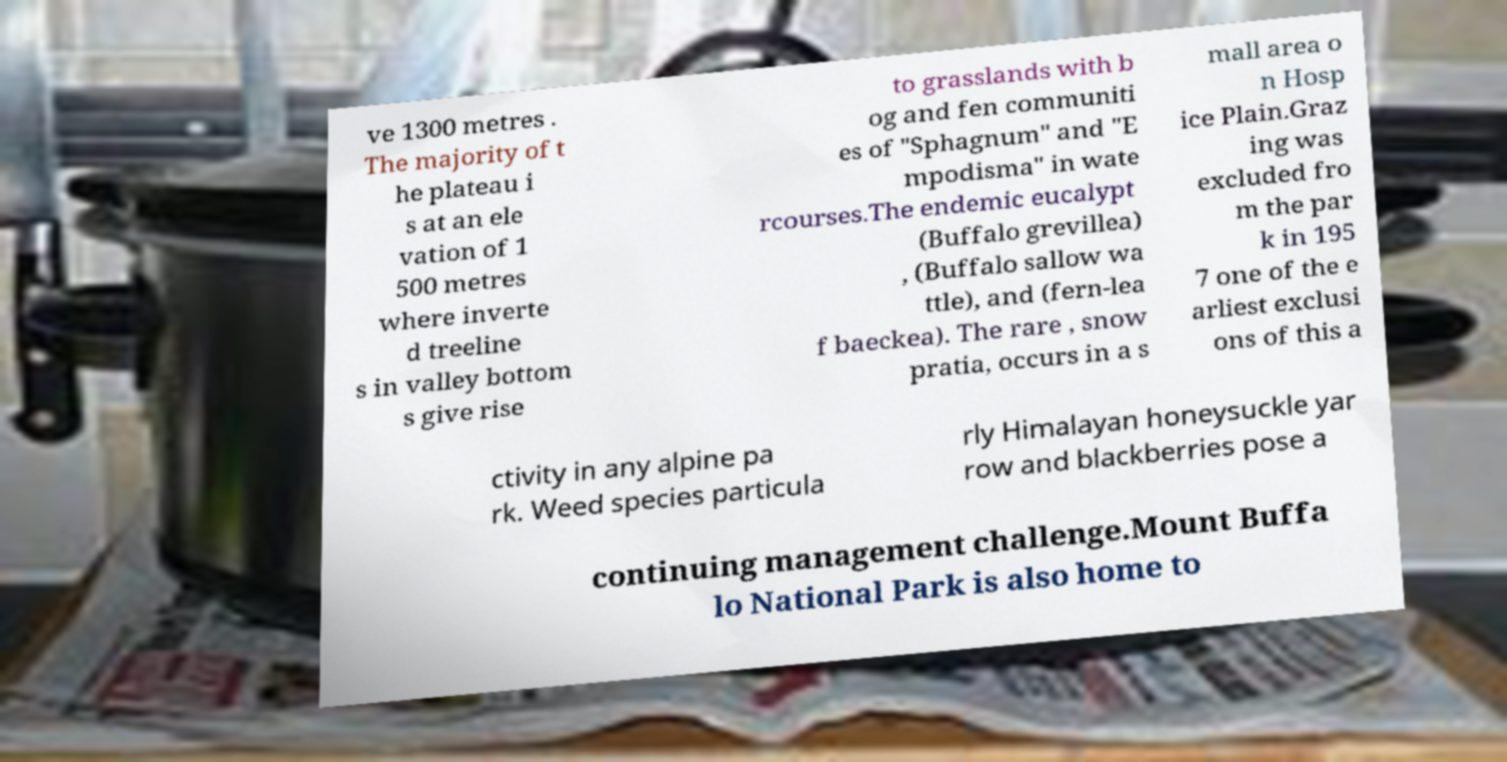Can you read and provide the text displayed in the image?This photo seems to have some interesting text. Can you extract and type it out for me? ve 1300 metres . The majority of t he plateau i s at an ele vation of 1 500 metres where inverte d treeline s in valley bottom s give rise to grasslands with b og and fen communiti es of "Sphagnum" and "E mpodisma" in wate rcourses.The endemic eucalypt (Buffalo grevillea) , (Buffalo sallow wa ttle), and (fern-lea f baeckea). The rare , snow pratia, occurs in a s mall area o n Hosp ice Plain.Graz ing was excluded fro m the par k in 195 7 one of the e arliest exclusi ons of this a ctivity in any alpine pa rk. Weed species particula rly Himalayan honeysuckle yar row and blackberries pose a continuing management challenge.Mount Buffa lo National Park is also home to 